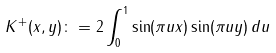Convert formula to latex. <formula><loc_0><loc_0><loc_500><loc_500>K ^ { + } ( x , y ) \colon = 2 \int _ { 0 } ^ { 1 } \sin ( \pi u x ) \sin ( \pi u y ) \, d u</formula> 